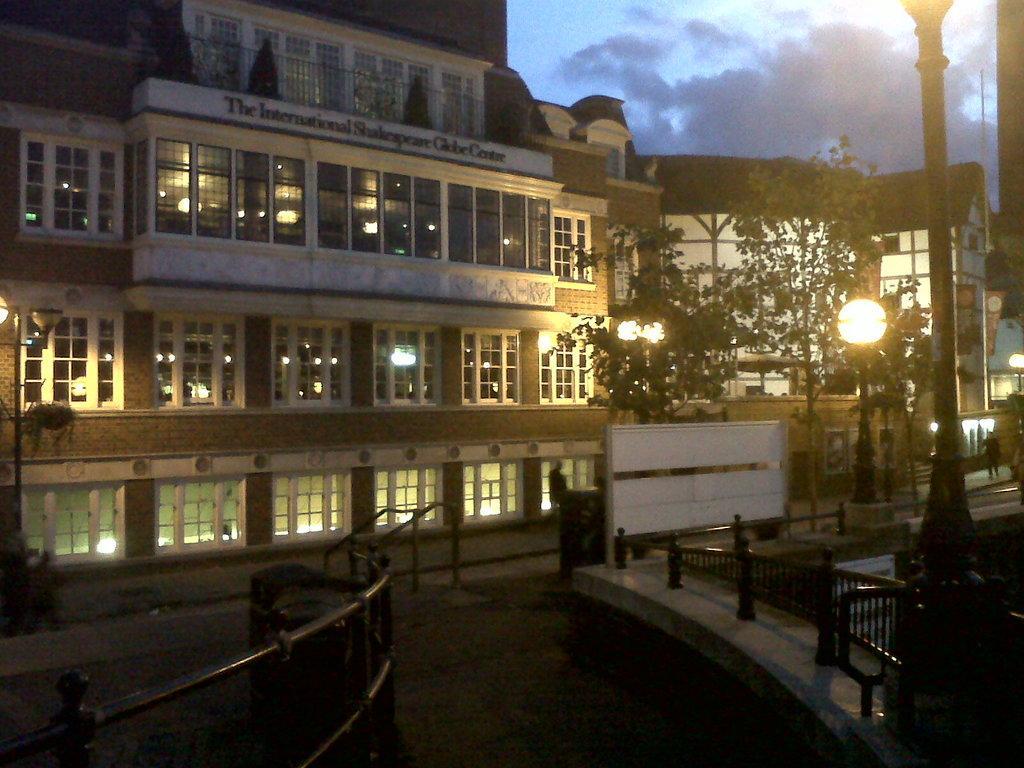Could you give a brief overview of what you see in this image? In this image I can see the road. To the side of the road there is a railing. In the background I can see the building with windows. There are trees and the lights to the side of the building. To the right I can see one person standing. In the back there are clouds and the blue sky. 